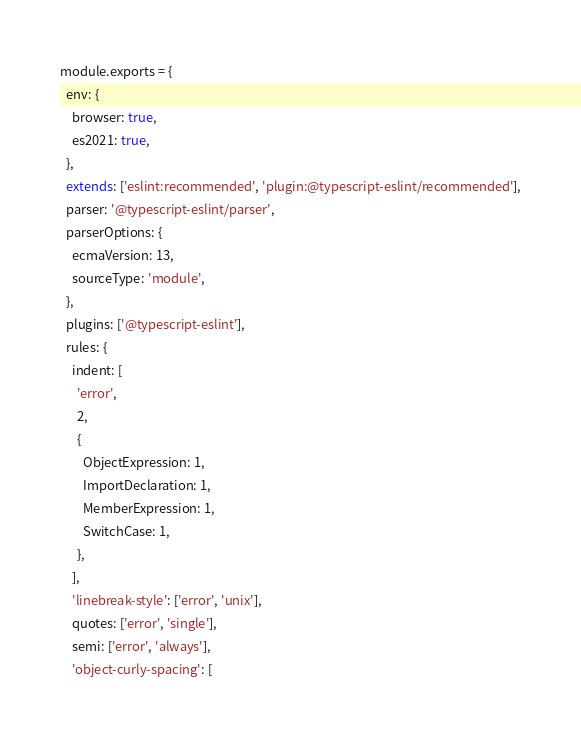Convert code to text. <code><loc_0><loc_0><loc_500><loc_500><_JavaScript_>module.exports = {
  env: {
    browser: true,
    es2021: true,
  },
  extends: ['eslint:recommended', 'plugin:@typescript-eslint/recommended'],
  parser: '@typescript-eslint/parser',
  parserOptions: {
    ecmaVersion: 13,
    sourceType: 'module',
  },
  plugins: ['@typescript-eslint'],
  rules: {
    indent: [
      'error',
      2,
      {
        ObjectExpression: 1,
        ImportDeclaration: 1,
        MemberExpression: 1,
        SwitchCase: 1,
      },
    ],
    'linebreak-style': ['error', 'unix'],
    quotes: ['error', 'single'],
    semi: ['error', 'always'],
    'object-curly-spacing': [</code> 